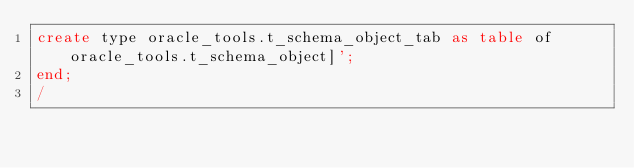<code> <loc_0><loc_0><loc_500><loc_500><_SQL_>create type oracle_tools.t_schema_object_tab as table of oracle_tools.t_schema_object]';
end;
/
</code> 